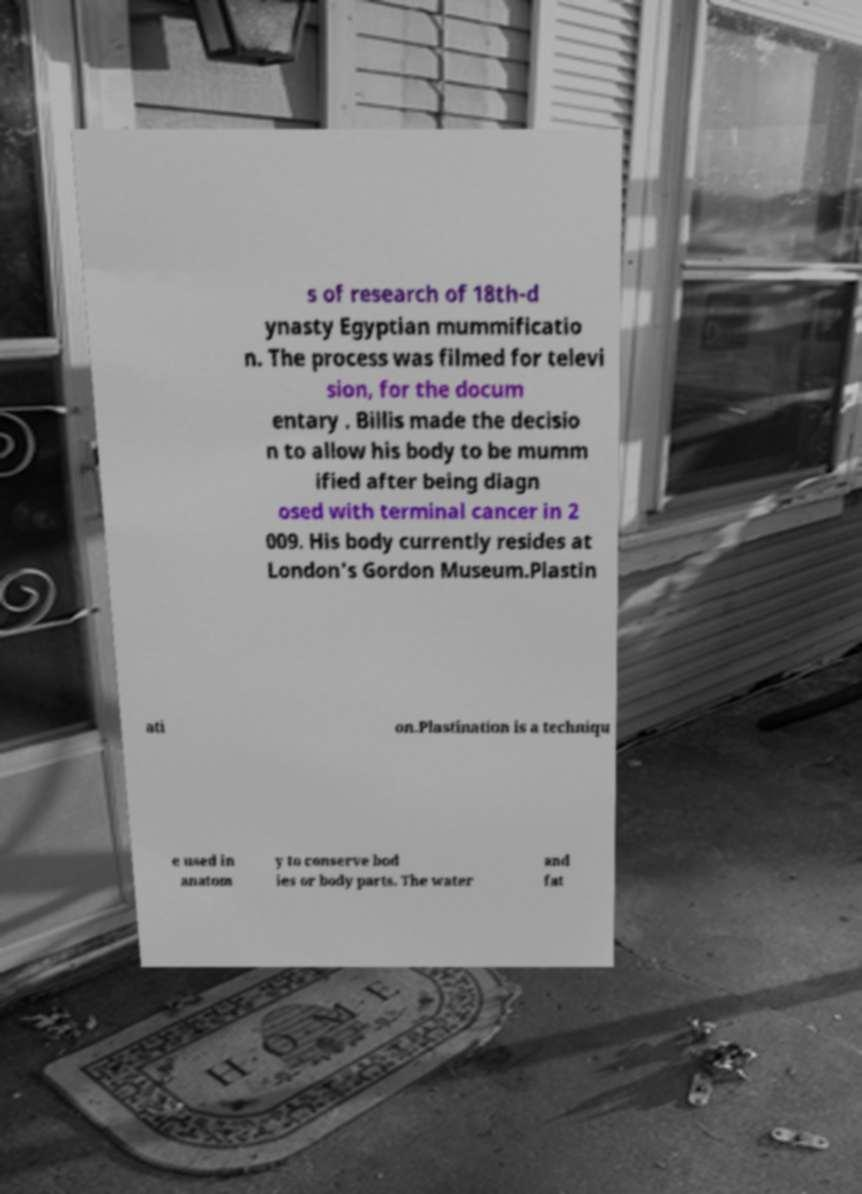For documentation purposes, I need the text within this image transcribed. Could you provide that? s of research of 18th-d ynasty Egyptian mummificatio n. The process was filmed for televi sion, for the docum entary . Billis made the decisio n to allow his body to be mumm ified after being diagn osed with terminal cancer in 2 009. His body currently resides at London's Gordon Museum.Plastin ati on.Plastination is a techniqu e used in anatom y to conserve bod ies or body parts. The water and fat 